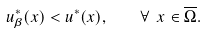<formula> <loc_0><loc_0><loc_500><loc_500>u ^ { * } _ { \beta } ( x ) < u ^ { * } ( x ) , \quad \forall \ x \in \overline { \Omega } .</formula> 